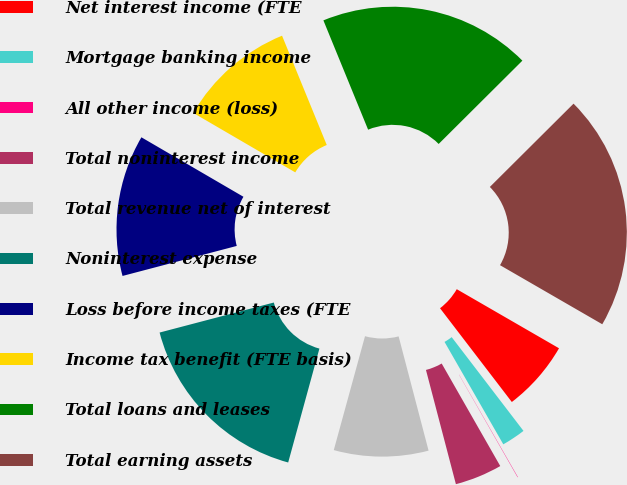Convert chart. <chart><loc_0><loc_0><loc_500><loc_500><pie_chart><fcel>Net interest income (FTE<fcel>Mortgage banking income<fcel>All other income (loss)<fcel>Total noninterest income<fcel>Total revenue net of interest<fcel>Noninterest expense<fcel>Loss before income taxes (FTE<fcel>Income tax benefit (FTE basis)<fcel>Total loans and leases<fcel>Total earning assets<nl><fcel>6.26%<fcel>2.11%<fcel>0.03%<fcel>4.18%<fcel>8.34%<fcel>16.65%<fcel>12.49%<fcel>10.42%<fcel>18.72%<fcel>20.8%<nl></chart> 